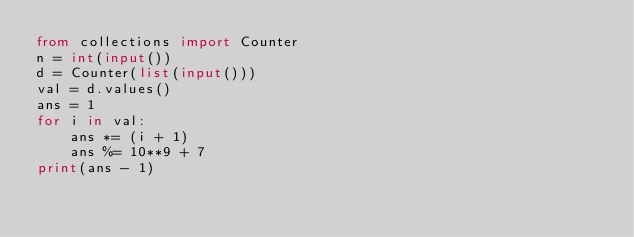Convert code to text. <code><loc_0><loc_0><loc_500><loc_500><_Python_>from collections import Counter
n = int(input())
d = Counter(list(input()))
val = d.values()
ans = 1
for i in val:
    ans *= (i + 1)
    ans %= 10**9 + 7
print(ans - 1)</code> 